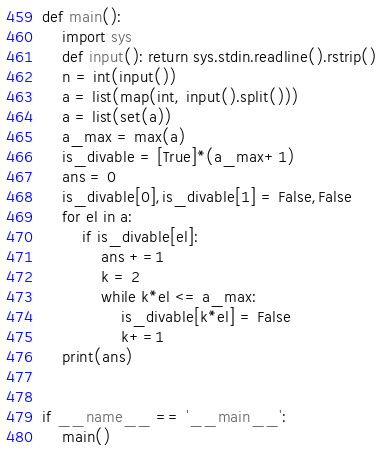<code> <loc_0><loc_0><loc_500><loc_500><_Python_>def main():
    import sys
    def input(): return sys.stdin.readline().rstrip()
    n = int(input())
    a = list(map(int, input().split()))
    a = list(set(a))
    a_max = max(a)
    is_divable = [True]*(a_max+1)
    ans = 0
    is_divable[0],is_divable[1] = False,False
    for el in a:
        if is_divable[el]:
            ans +=1
            k = 2
            while k*el <= a_max:
                is_divable[k*el] = False
                k+=1
    print(ans)


if __name__ == '__main__':
    main()
</code> 